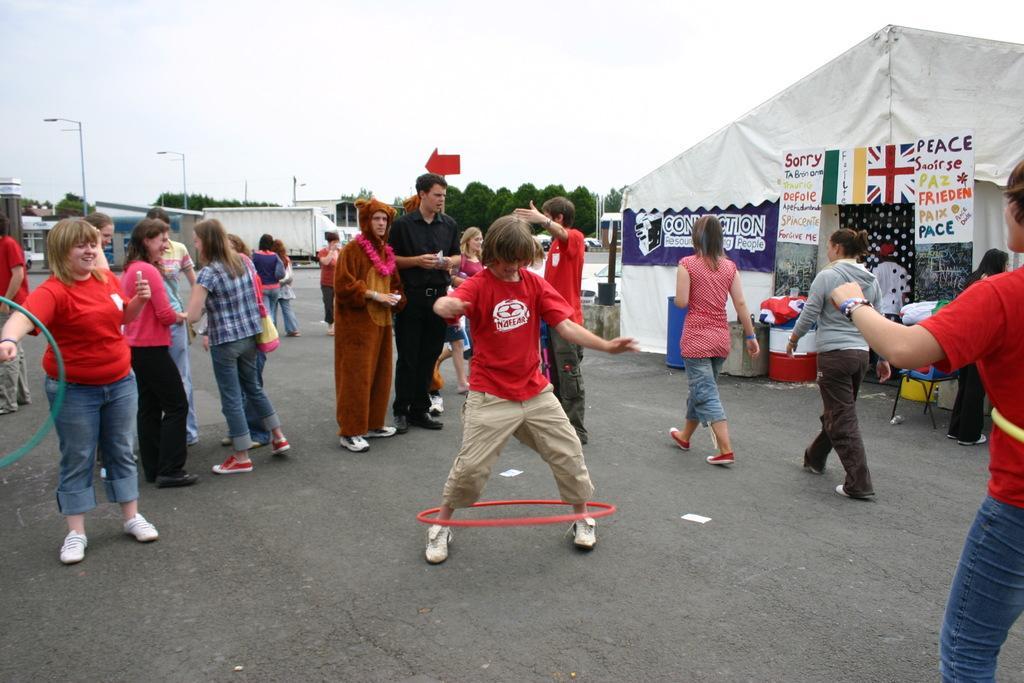Could you give a brief overview of what you see in this image? In this image, in the middle there is a boy, he wears a t shirt, trouser, he is playing with ring. On the left there is a woman, she wears a t shirt, trouser, shoes, she is playing with ring. On the right there are two women, they are walking. In the middle there are people, tents, posters, chairs, trees, street lights, road, sky and clouds. 